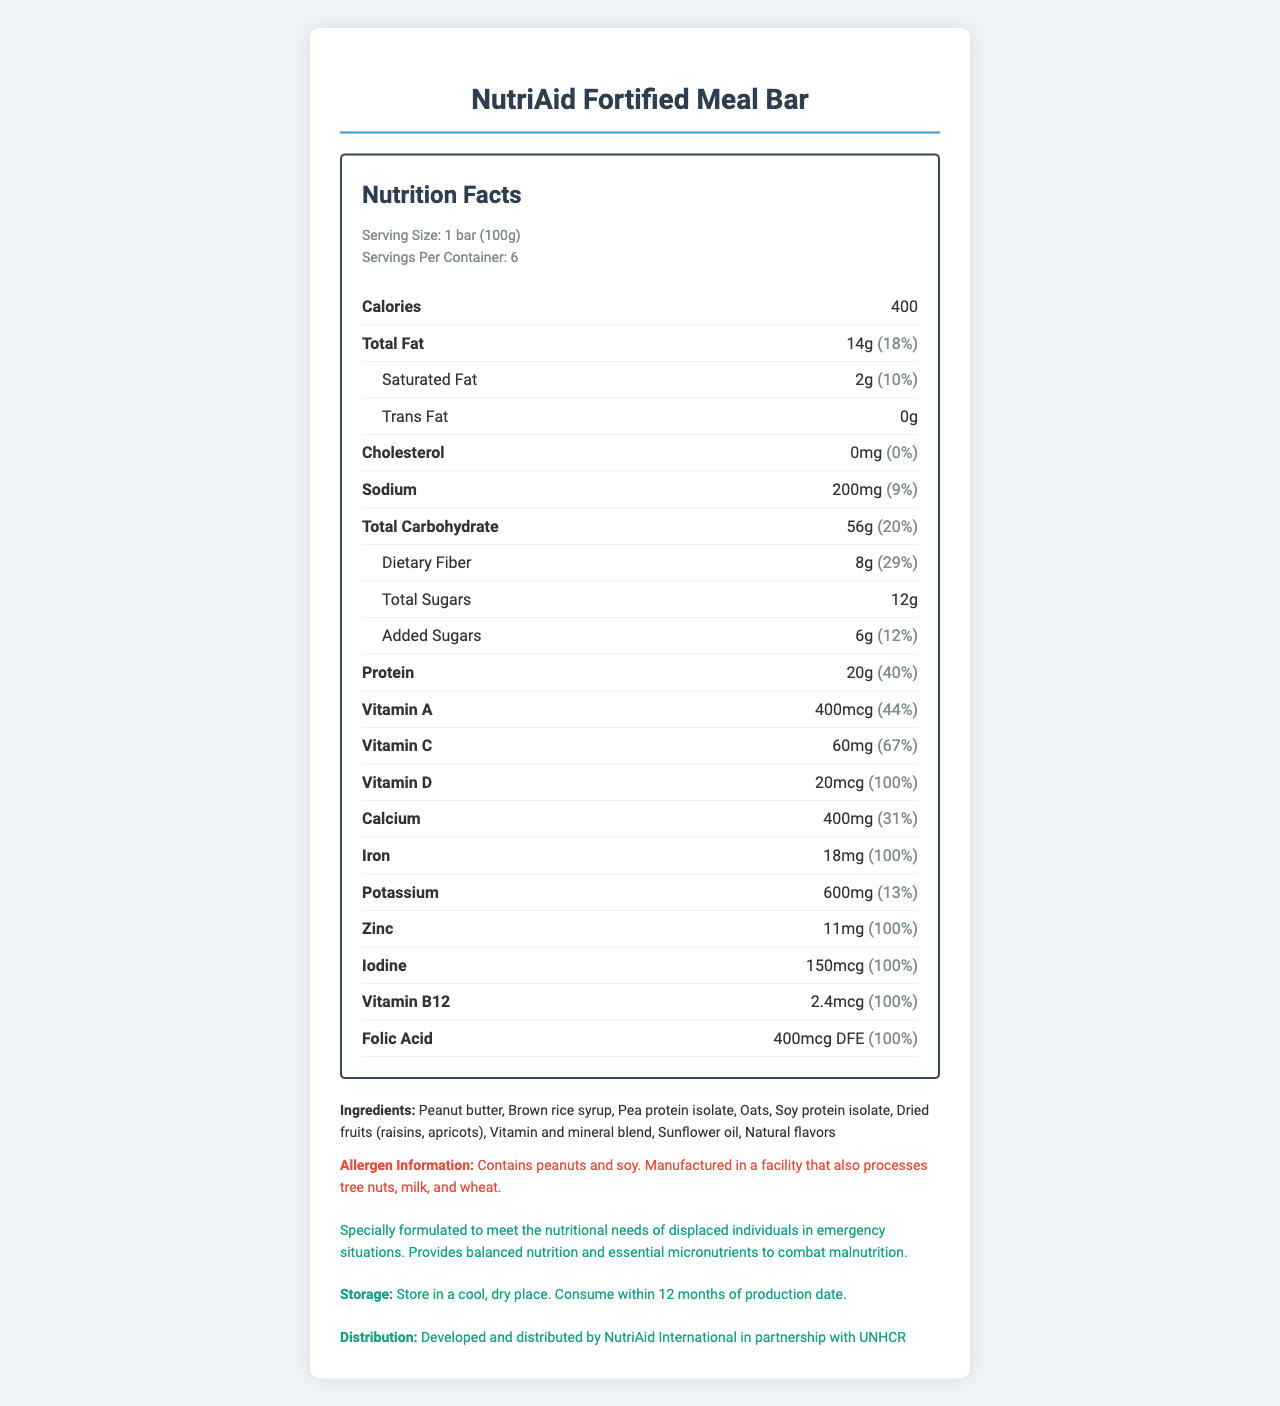what is the serving size of the NutriAid Fortified Meal Bar? Serving size is explicitly stated as "1 bar (100g)" in the nutrition facts section.
Answer: 1 bar (100g) how many servings are there per container? The document specifies "Servings Per Container: 6".
Answer: 6 what is the total amount of calories in one serving? The calories per serving are mentioned in the nutrition facts as "Calories 400".
Answer: 400 how much dietary fiber does one bar contain? Under the total carbohydrate section, the document lists "Dietary Fiber: 8g".
Answer: 8g what is the amount of added sugars per serving? The added sugars are explicitly mentioned as "Added Sugars: 6g".
Answer: 6g how much Iron does the meal bar provide per serving? A. 15mg B. 18mg C. 20mg D. 25mg The nutrient section specifies "Iron: 18mg".
Answer: B what percentage of the daily value for Vitamin C does one serving offer? A. 44% B. 67% C. 100% D. 29% The daily value percentage for Vitamin C is mentioned as "67%".
Answer: B does the meal bar contain Vitamin B12? It is listed under the nutrients as "Vitamin B12: 2.4mcg".
Answer: Yes can the NutriAid Fortified Meal Bar be considered allergenic for someone with a peanut allergy? The allergen information clearly states "Contains peanuts".
Answer: Yes summarize the main purpose and usage of the NutriAid Fortified Meal Bar. The document highlights the purpose of the bar to combat malnutrition among displaced populations, offering comprehensive nutritional support.
Answer: The NutriAid Fortified Meal Bar is designed to meet the nutritional needs of malnourished displaced individuals, providing balanced nutrition and essential micronutrients in emergency situations. how many total carbohydrates are there in one serving of the NutriAid Fortified Meal Bar? The total carbohydrate content is listed as "Total Carbohydrate: 56g".
Answer: 56g what is the main ingredient in the NutriAid Fortified Meal Bar? The ingredients section lists peanut butter as the first ingredient.
Answer: Peanut butter is there any cholesterol in the NutriAid Fortified Meal Bar? Cholesterol content is listed as "0mg" with a daily value percentage of "0%".
Answer: No where should the NutriAid Fortified Meal Bar be stored? Storage instructions specify to "Store in a cool, dry place".
Answer: In a cool, dry place what organization is involved in the distribution of the NutriAid Fortified Meal Bar? The distribution information mentions that it is "Developed and distributed by NutriAid International in partnership with UNHCR".
Answer: UNHCR what is the total fat content per serving? The total fat amount is listed as "Total Fat: 14g".
Answer: 14g what is the production date of the NutriAid Fortified Meal Bar? The document mentions storing and consuming within 12 months of production but doesn't specify the production date itself.
Answer: Cannot be determined 